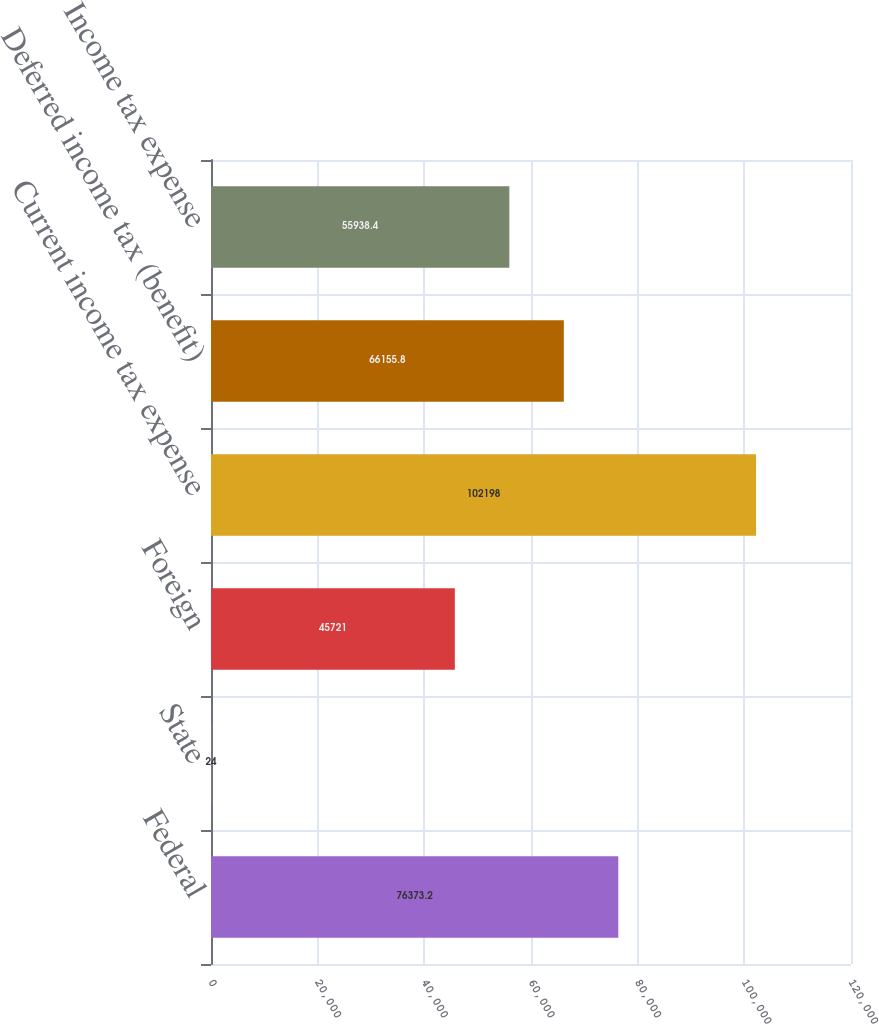<chart> <loc_0><loc_0><loc_500><loc_500><bar_chart><fcel>Federal<fcel>State<fcel>Foreign<fcel>Current income tax expense<fcel>Deferred income tax (benefit)<fcel>Income tax expense<nl><fcel>76373.2<fcel>24<fcel>45721<fcel>102198<fcel>66155.8<fcel>55938.4<nl></chart> 